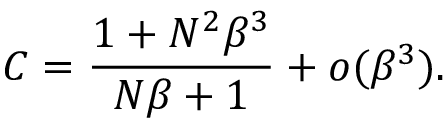<formula> <loc_0><loc_0><loc_500><loc_500>C = \frac { 1 + N ^ { 2 } \beta ^ { 3 } } { N \beta + 1 } + o ( \beta ^ { 3 } ) .</formula> 